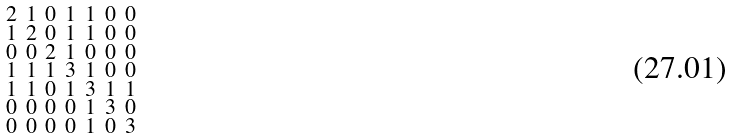<formula> <loc_0><loc_0><loc_500><loc_500>\begin{smallmatrix} 2 & 1 & 0 & 1 & 1 & 0 & 0 \\ 1 & 2 & 0 & 1 & 1 & 0 & 0 \\ 0 & 0 & 2 & 1 & 0 & 0 & 0 \\ 1 & 1 & 1 & 3 & 1 & 0 & 0 \\ 1 & 1 & 0 & 1 & 3 & 1 & 1 \\ 0 & 0 & 0 & 0 & 1 & 3 & 0 \\ 0 & 0 & 0 & 0 & 1 & 0 & 3 \end{smallmatrix}</formula> 